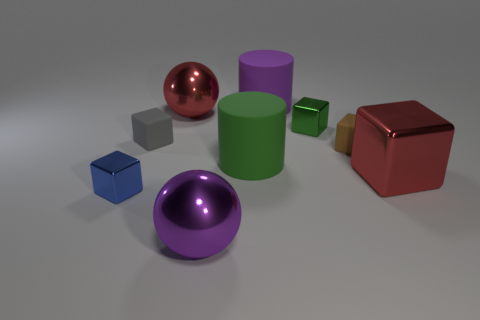Subtract all metallic cubes. How many cubes are left? 2 Subtract all gray cubes. How many cubes are left? 4 Add 1 green matte things. How many objects exist? 10 Subtract all balls. How many objects are left? 7 Add 5 tiny red spheres. How many tiny red spheres exist? 5 Subtract 1 brown blocks. How many objects are left? 8 Subtract all gray cylinders. Subtract all yellow cubes. How many cylinders are left? 2 Subtract all big red spheres. Subtract all green shiny objects. How many objects are left? 7 Add 3 brown matte cubes. How many brown matte cubes are left? 4 